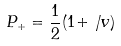Convert formula to latex. <formula><loc_0><loc_0><loc_500><loc_500>P _ { + } = \frac { 1 } { 2 } ( 1 + \not \, v )</formula> 